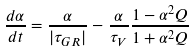<formula> <loc_0><loc_0><loc_500><loc_500>\frac { d \alpha } { d t } = \frac { \alpha } { | \tau _ { G R } | } - \frac { \alpha } { \tau _ { V } } \frac { 1 - \alpha ^ { 2 } Q } { 1 + \alpha ^ { 2 } Q }</formula> 